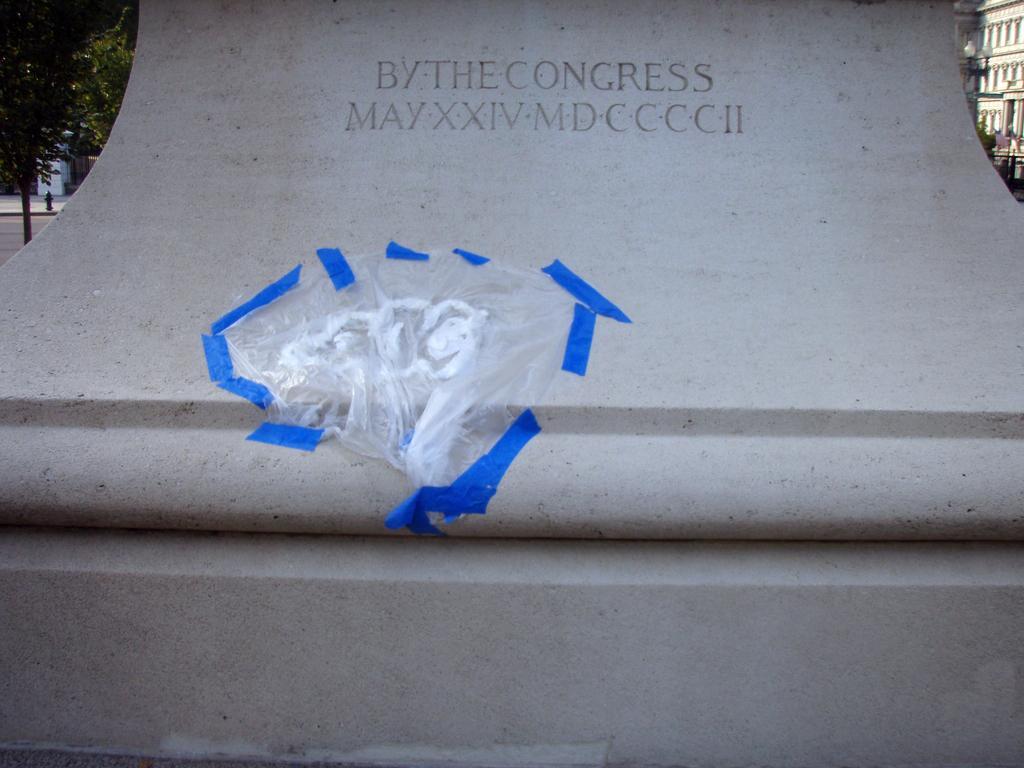How would you summarize this image in a sentence or two? Something written on this wall. Left side of the image there is a tree. Right side of the image there is a building and light pole. 